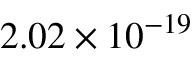Convert formula to latex. <formula><loc_0><loc_0><loc_500><loc_500>2 . 0 2 \times 1 0 ^ { - 1 9 }</formula> 